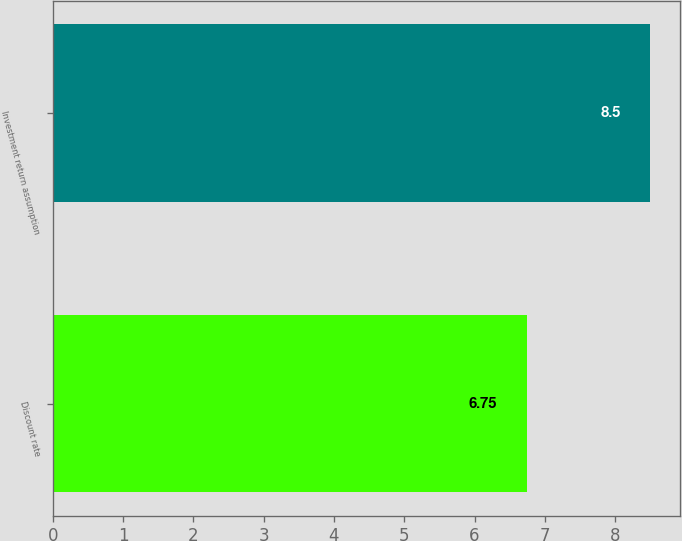Convert chart to OTSL. <chart><loc_0><loc_0><loc_500><loc_500><bar_chart><fcel>Discount rate<fcel>Investment return assumption<nl><fcel>6.75<fcel>8.5<nl></chart> 